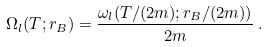Convert formula to latex. <formula><loc_0><loc_0><loc_500><loc_500>\Omega _ { l } ( T ; r _ { B } ) = \frac { \omega _ { l } ( T / ( 2 m ) ; r _ { B } / ( 2 m ) ) } { 2 m } \, .</formula> 